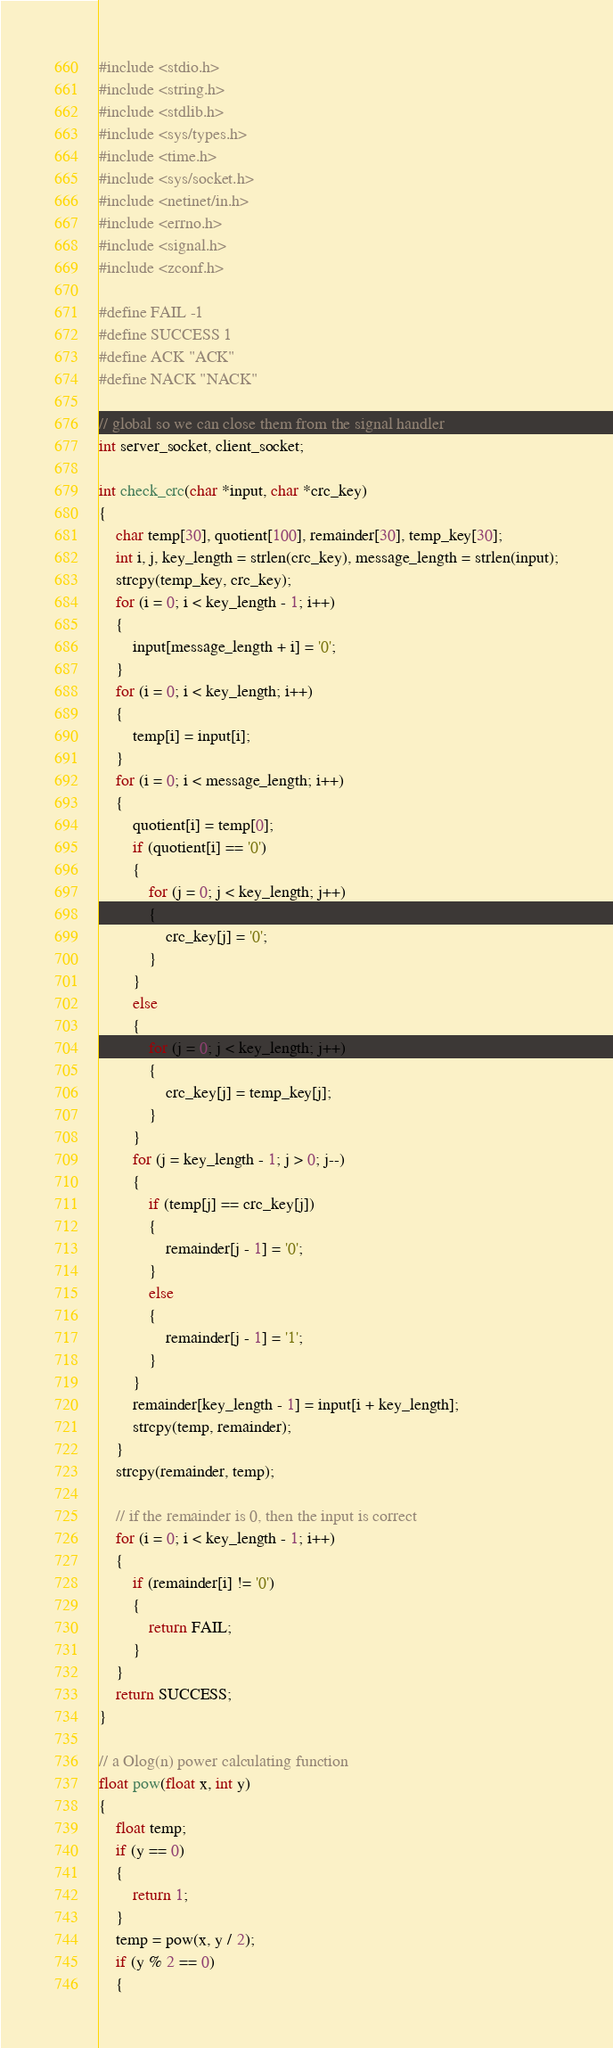<code> <loc_0><loc_0><loc_500><loc_500><_C_>#include <stdio.h>
#include <string.h>
#include <stdlib.h>
#include <sys/types.h>
#include <time.h>
#include <sys/socket.h>
#include <netinet/in.h>
#include <errno.h>
#include <signal.h>
#include <zconf.h>

#define FAIL -1
#define SUCCESS 1
#define ACK "ACK"
#define NACK "NACK"

// global so we can close them from the signal handler
int server_socket, client_socket;

int check_crc(char *input, char *crc_key)
{
    char temp[30], quotient[100], remainder[30], temp_key[30];
    int i, j, key_length = strlen(crc_key), message_length = strlen(input);
    strcpy(temp_key, crc_key);
    for (i = 0; i < key_length - 1; i++)
    {
        input[message_length + i] = '0';
    }
    for (i = 0; i < key_length; i++)
    {
        temp[i] = input[i];
    }
    for (i = 0; i < message_length; i++)
    {
        quotient[i] = temp[0];
        if (quotient[i] == '0')
        {
            for (j = 0; j < key_length; j++)
            {
                crc_key[j] = '0';
            }
        }
        else
        {
            for (j = 0; j < key_length; j++)
            {
                crc_key[j] = temp_key[j];
            }
        }
        for (j = key_length - 1; j > 0; j--)
        {
            if (temp[j] == crc_key[j])
            {
                remainder[j - 1] = '0';
            }
            else
            {
                remainder[j - 1] = '1';
            }
        }
        remainder[key_length - 1] = input[i + key_length];
        strcpy(temp, remainder);
    }
    strcpy(remainder, temp);

    // if the remainder is 0, then the input is correct
    for (i = 0; i < key_length - 1; i++)
    {
        if (remainder[i] != '0')
        {
            return FAIL;
        }
    }
    return SUCCESS;
}

// a Olog(n) power calculating function
float pow(float x, int y)
{
    float temp;
    if (y == 0)
    {
        return 1;
    }
    temp = pow(x, y / 2);
    if (y % 2 == 0)
    {</code> 